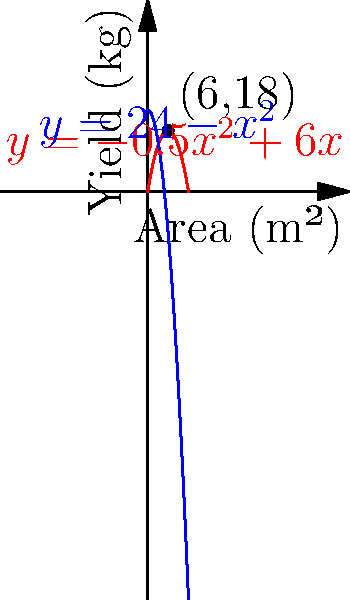Big Big Wolf wants to maximize his vegetable yield in a garden plot near Pleasant Goat's village. He models two different vegetable types:

1. Red vegetables: $y = -0.5x^2 + 6x$
2. Blue vegetables: $y = 24 - x^2$

Where $x$ is the area of the garden in square meters, and $y$ is the yield in kilograms.

At what garden area will both vegetable types produce the same yield, and what is that yield? To solve this problem, we need to follow these steps:

1) First, we need to find where the two functions intersect. This occurs when:

   $-0.5x^2 + 6x = 24 - x^2$

2) Rearranging the equation:

   $-0.5x^2 + 6x - (24 - x^2) = 0$
   $0.5x^2 + 6x - 24 = 0$

3) This is a quadratic equation. We can solve it using the quadratic formula:
   $x = \frac{-b \pm \sqrt{b^2 - 4ac}}{2a}$

   Where $a = 0.5$, $b = 6$, and $c = -24$

4) Plugging into the formula:

   $x = \frac{-6 \pm \sqrt{36 - 4(0.5)(-24)}}{2(0.5)}$
   $= \frac{-6 \pm \sqrt{36 + 48}}{1}$
   $= \frac{-6 \pm \sqrt{84}}{1}$
   $= -6 \pm \sqrt{84}$

5) This gives us two solutions:
   $x_1 = -6 + \sqrt{84} \approx 3.17$
   $x_2 = -6 - \sqrt{84} \approx -15.17$

6) Since area can't be negative, we discard the negative solution. The intersection occurs at $x = 6$ (rounded to the nearest integer).

7) To find the yield at this point, we can plug $x = 6$ into either equation:

   $y = -0.5(6)^2 + 6(6) = -18 + 36 = 18$

Therefore, both vegetable types will produce the same yield of 18 kg when the garden area is 6 m².
Answer: 6 m² area, 18 kg yield 